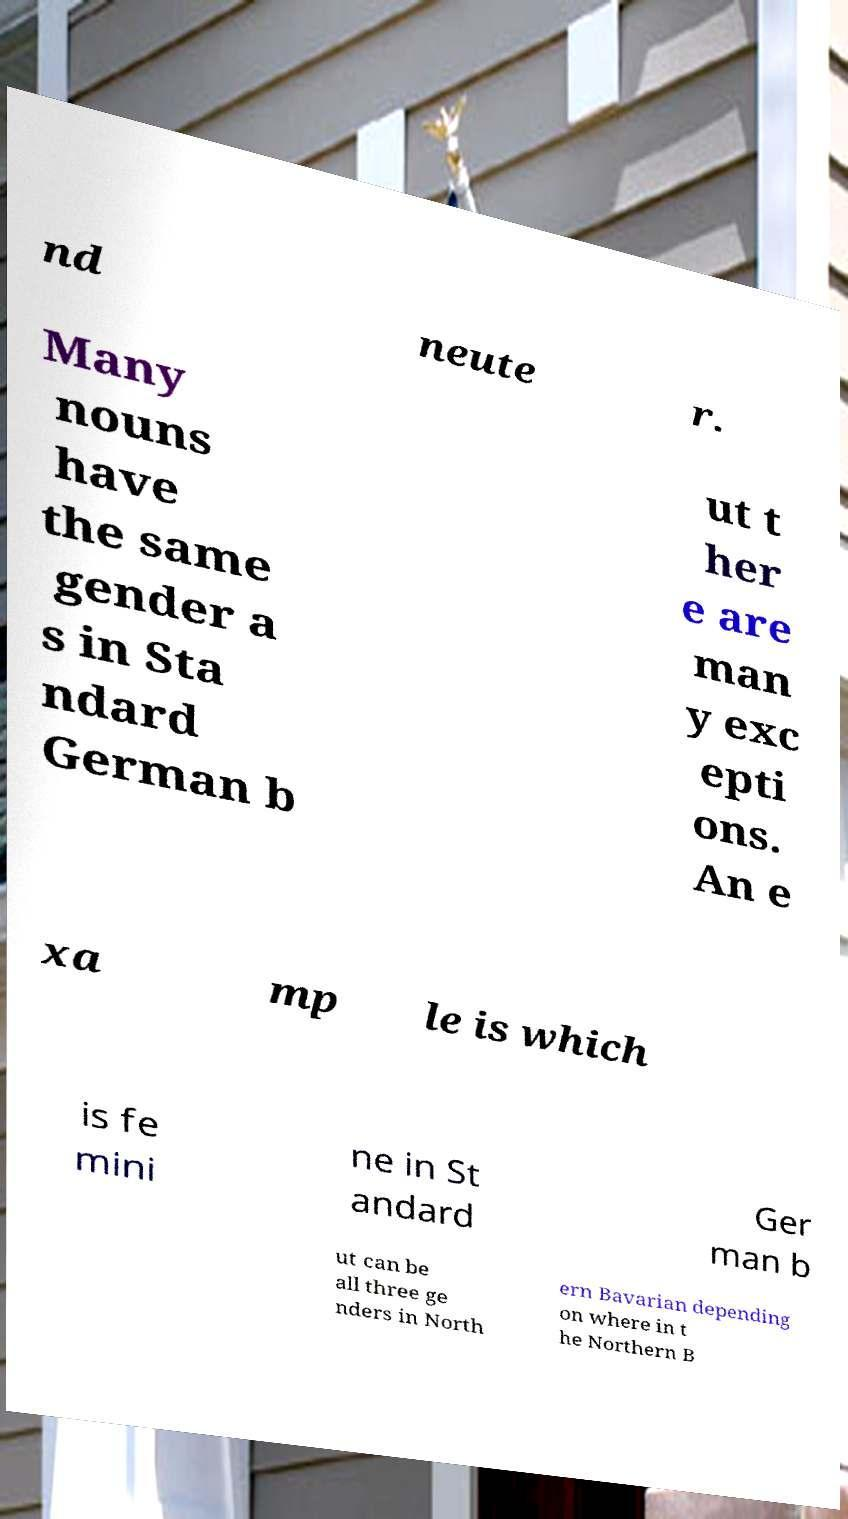There's text embedded in this image that I need extracted. Can you transcribe it verbatim? nd neute r. Many nouns have the same gender a s in Sta ndard German b ut t her e are man y exc epti ons. An e xa mp le is which is fe mini ne in St andard Ger man b ut can be all three ge nders in North ern Bavarian depending on where in t he Northern B 